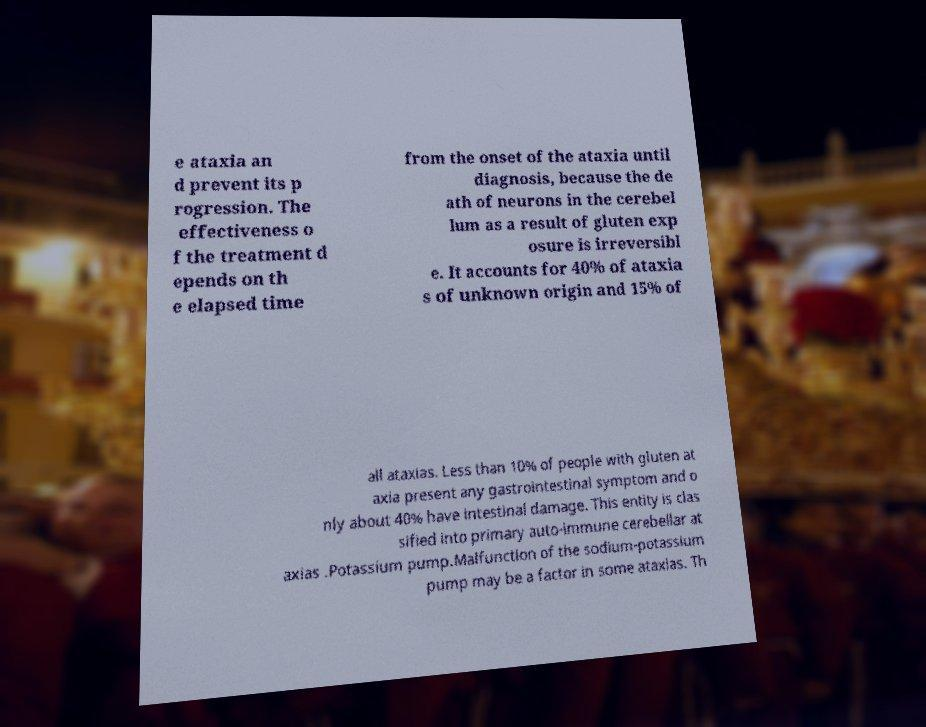Please read and relay the text visible in this image. What does it say? e ataxia an d prevent its p rogression. The effectiveness o f the treatment d epends on th e elapsed time from the onset of the ataxia until diagnosis, because the de ath of neurons in the cerebel lum as a result of gluten exp osure is irreversibl e. It accounts for 40% of ataxia s of unknown origin and 15% of all ataxias. Less than 10% of people with gluten at axia present any gastrointestinal symptom and o nly about 40% have intestinal damage. This entity is clas sified into primary auto-immune cerebellar at axias .Potassium pump.Malfunction of the sodium-potassium pump may be a factor in some ataxias. Th 